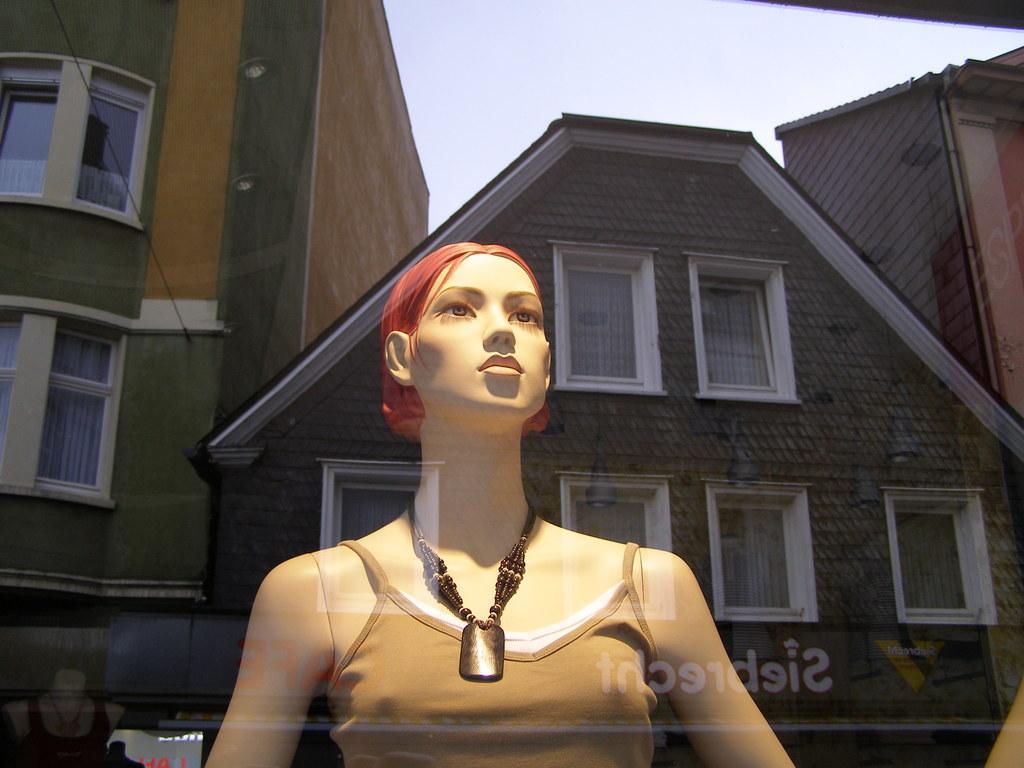How would you summarize this image in a sentence or two? In this image, we can see a mannequin wearing a chain and in the background, there are buildings and at the bottom, we can see some text. At the top, there is sky. 